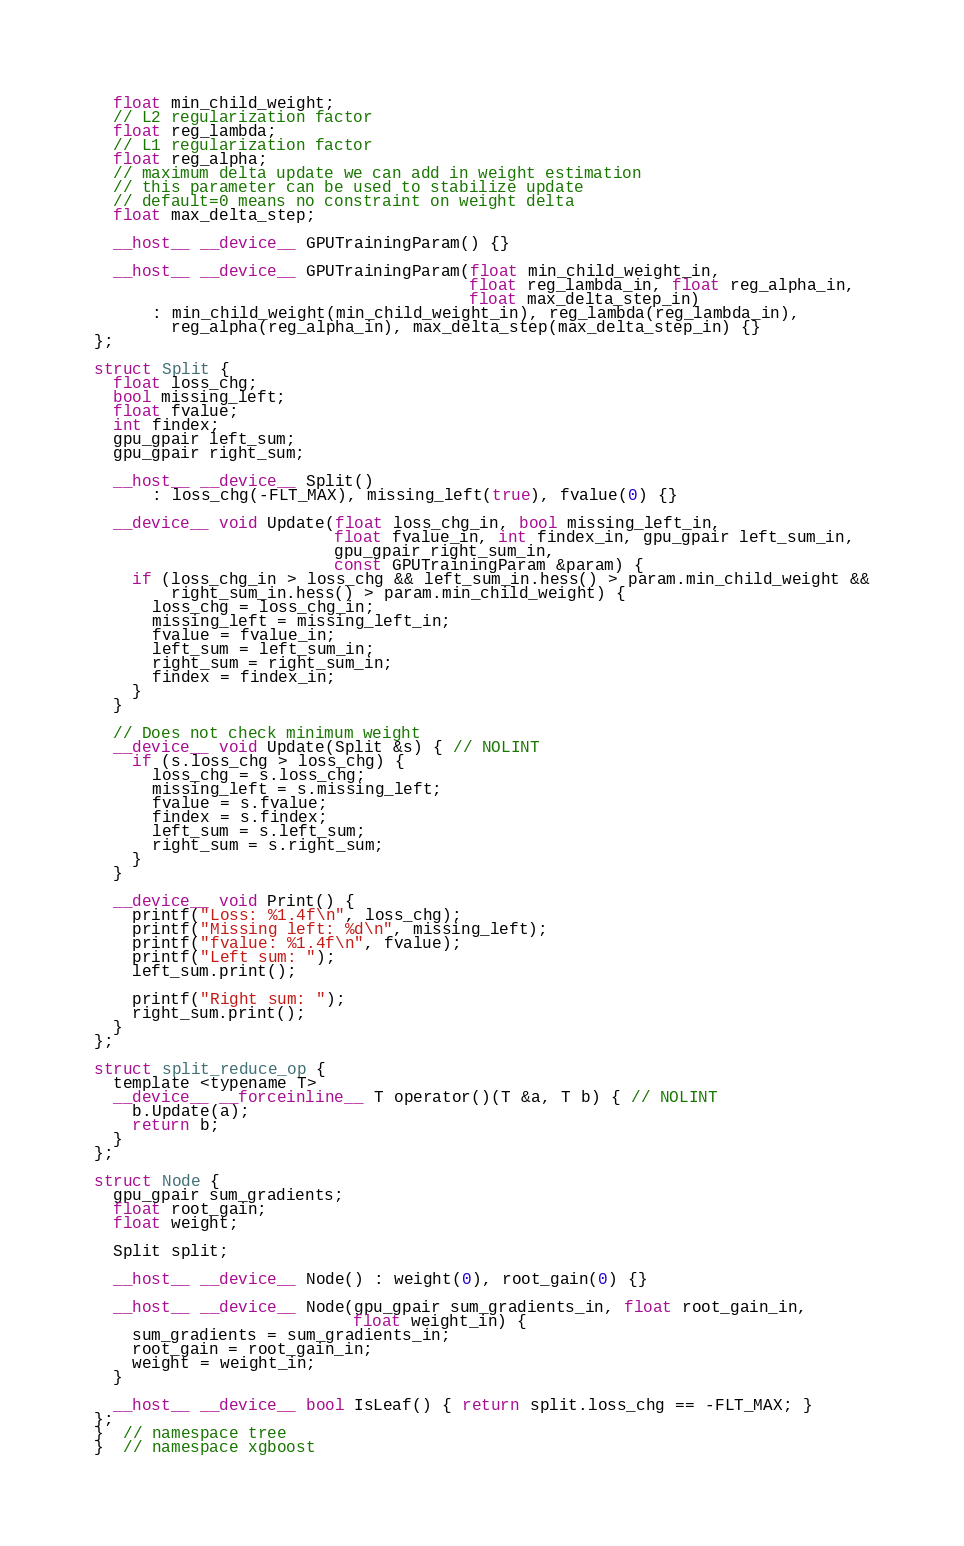<code> <loc_0><loc_0><loc_500><loc_500><_Cuda_>  float min_child_weight;
  // L2 regularization factor
  float reg_lambda;
  // L1 regularization factor
  float reg_alpha;
  // maximum delta update we can add in weight estimation
  // this parameter can be used to stabilize update
  // default=0 means no constraint on weight delta
  float max_delta_step;

  __host__ __device__ GPUTrainingParam() {}

  __host__ __device__ GPUTrainingParam(float min_child_weight_in,
                                       float reg_lambda_in, float reg_alpha_in,
                                       float max_delta_step_in)
      : min_child_weight(min_child_weight_in), reg_lambda(reg_lambda_in),
        reg_alpha(reg_alpha_in), max_delta_step(max_delta_step_in) {}
};

struct Split {
  float loss_chg;
  bool missing_left;
  float fvalue;
  int findex;
  gpu_gpair left_sum;
  gpu_gpair right_sum;

  __host__ __device__ Split()
      : loss_chg(-FLT_MAX), missing_left(true), fvalue(0) {}

  __device__ void Update(float loss_chg_in, bool missing_left_in,
                         float fvalue_in, int findex_in, gpu_gpair left_sum_in,
                         gpu_gpair right_sum_in,
                         const GPUTrainingParam &param) {
    if (loss_chg_in > loss_chg && left_sum_in.hess() > param.min_child_weight &&
        right_sum_in.hess() > param.min_child_weight) {
      loss_chg = loss_chg_in;
      missing_left = missing_left_in;
      fvalue = fvalue_in;
      left_sum = left_sum_in;
      right_sum = right_sum_in;
      findex = findex_in;
    }
  }

  // Does not check minimum weight
  __device__ void Update(Split &s) { // NOLINT
    if (s.loss_chg > loss_chg) {
      loss_chg = s.loss_chg;
      missing_left = s.missing_left;
      fvalue = s.fvalue;
      findex = s.findex;
      left_sum = s.left_sum;
      right_sum = s.right_sum;
    }
  }

  __device__ void Print() {
    printf("Loss: %1.4f\n", loss_chg);
    printf("Missing left: %d\n", missing_left);
    printf("fvalue: %1.4f\n", fvalue);
    printf("Left sum: ");
    left_sum.print();

    printf("Right sum: ");
    right_sum.print();
  }
};

struct split_reduce_op {
  template <typename T>
  __device__ __forceinline__ T operator()(T &a, T b) { // NOLINT
    b.Update(a);
    return b;
  }
};

struct Node {
  gpu_gpair sum_gradients;
  float root_gain;
  float weight;

  Split split;

  __host__ __device__ Node() : weight(0), root_gain(0) {}

  __host__ __device__ Node(gpu_gpair sum_gradients_in, float root_gain_in,
                           float weight_in) {
    sum_gradients = sum_gradients_in;
    root_gain = root_gain_in;
    weight = weight_in;
  }

  __host__ __device__ bool IsLeaf() { return split.loss_chg == -FLT_MAX; }
};
}  // namespace tree
}  // namespace xgboost
</code> 